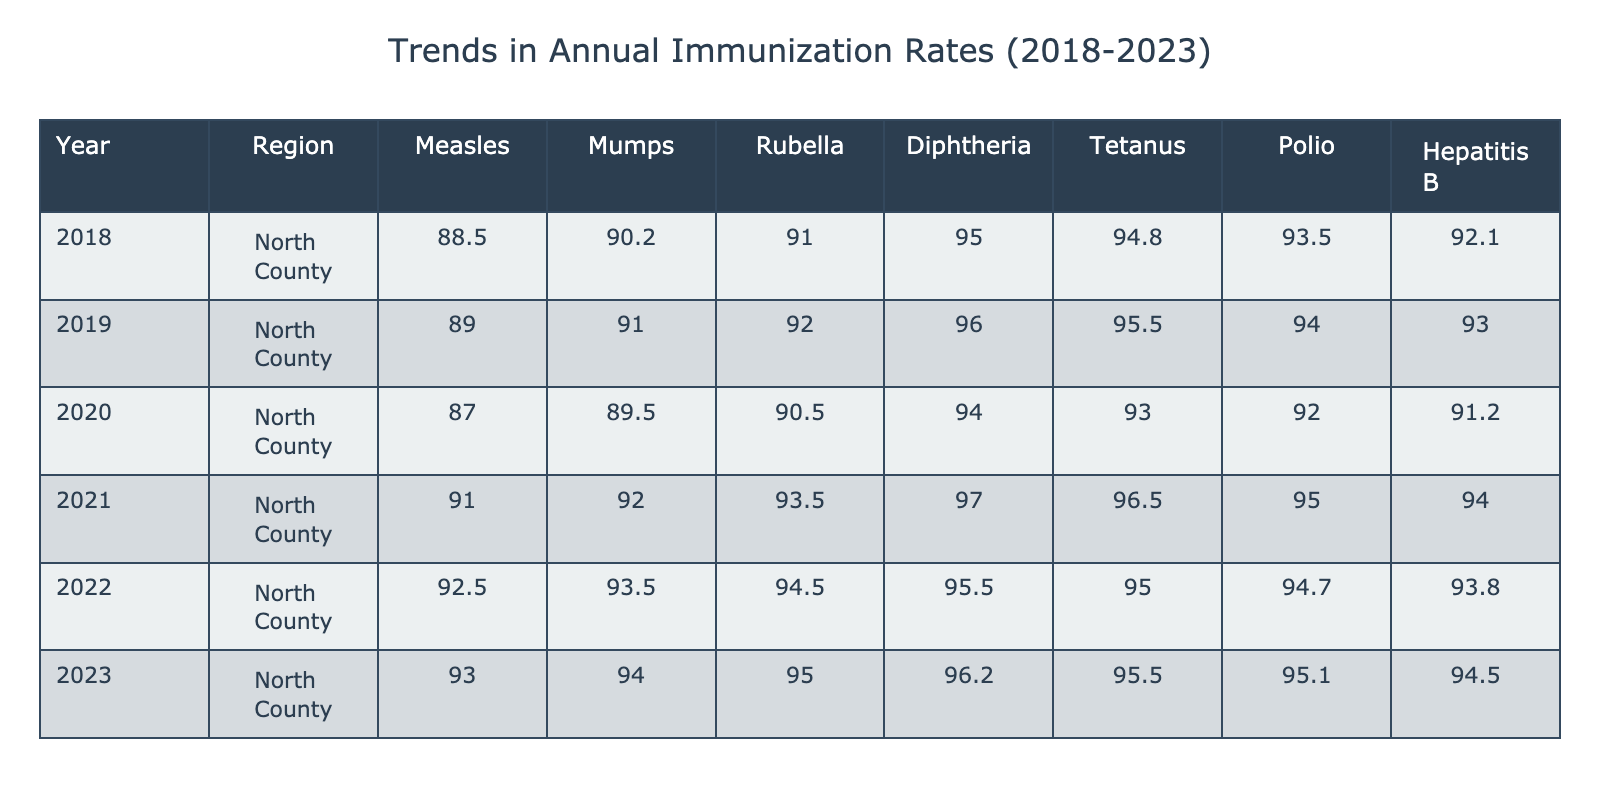What was the highest immunization rate for Measles in North County from 2018 to 2023? The highest immunization rate for Measles in North County is 93.0, which occurred in 2023. This is determined by scanning the Measles column and identifying the maximum value over the years provided.
Answer: 93.0 Which year showed the lowest immunization rate for Polio in North County? The lowest immunization rate for Polio in North County was 92.0, which occurred in 2020. This conclusion is made by checking the Polio column and identifying the minimum value for that year.
Answer: 2020 What was the average immunization rate for Rubella from 2018 to 2023? To calculate the average for Rubella, sum the values (91.0 + 92.0 + 90.5 + 93.5 + 94.5 + 95.0) = 456.5, and then divide this sum by the number of years, which is 6. The average is 456.5 / 6 = 76.08.
Answer: 76.08 Did the immunization rate for Diphtheria increase every year between 2018 and 2023 in North County? Observing the values for Diphtheria (95.0, 96.0, 94.0, 97.0, 95.5, 96.2), it is clear that the rate did not consistently increase each year, as it decreased from 2020 to 2021. Hence, the statement is false.
Answer: No What is the trend in immunization rates for Hepatitis B from 2018 to 2023 in North County? By examining the Hepatitis B data (92.1, 93.0, 91.2, 94.0, 93.8, 94.5), we see fluctuations; it increased in 2019, then decreased in 2020, climbing again in 2021 and 2023, indicating an overall positive trend despite some inconsistencies.
Answer: Fluctuating trend with an overall increase 